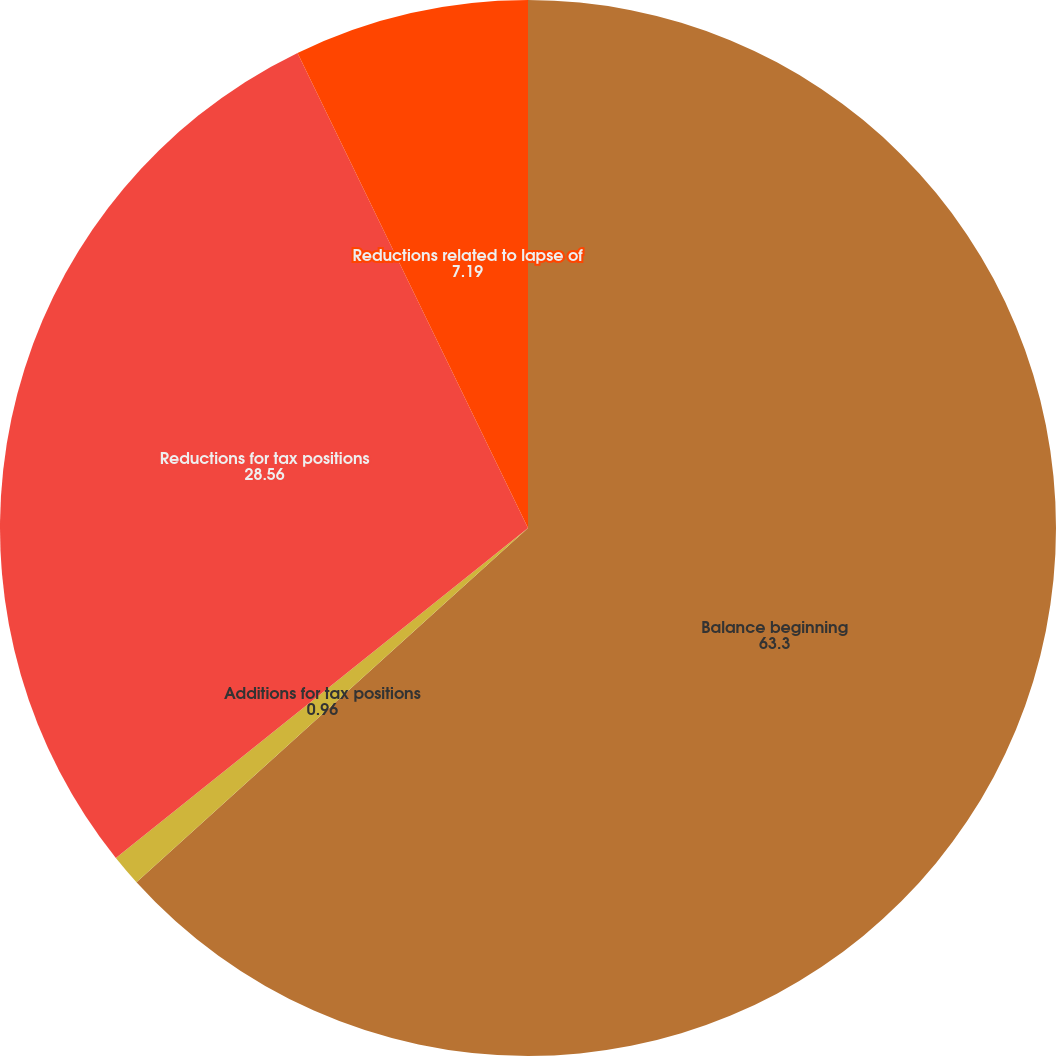<chart> <loc_0><loc_0><loc_500><loc_500><pie_chart><fcel>Balance beginning<fcel>Additions for tax positions<fcel>Reductions for tax positions<fcel>Reductions related to lapse of<nl><fcel>63.3%<fcel>0.96%<fcel>28.56%<fcel>7.19%<nl></chart> 